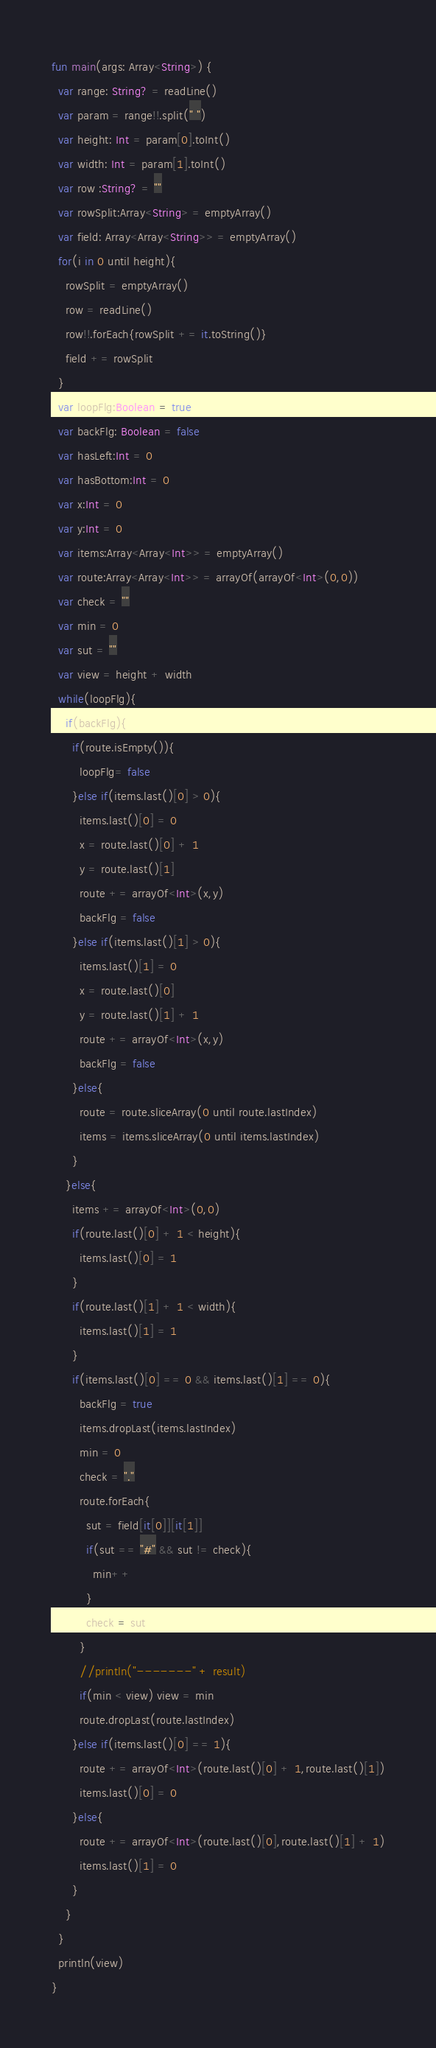<code> <loc_0><loc_0><loc_500><loc_500><_Kotlin_>fun main(args: Array<String>) {
  var range: String? = readLine()
  var param = range!!.split(" ")
  var height: Int = param[0].toInt()
  var width: Int = param[1].toInt()
  var row :String? = ""
  var rowSplit:Array<String> = emptyArray() 
  var field: Array<Array<String>> = emptyArray()
  for(i in 0 until height){
    rowSplit = emptyArray() 
    row = readLine()
    row!!.forEach{rowSplit += it.toString()}
    field += rowSplit
  }
  var loopFlg:Boolean = true
  var backFlg: Boolean = false
  var hasLeft:Int = 0
  var hasBottom:Int = 0
  var x:Int = 0
  var y:Int = 0
  var items:Array<Array<Int>> = emptyArray()
  var route:Array<Array<Int>> = arrayOf(arrayOf<Int>(0,0))
  var check = ""
  var min = 0
  var sut = ""
  var view = height + width
  while(loopFlg){
    if(backFlg){
      if(route.isEmpty()){
        loopFlg= false
      }else if(items.last()[0] > 0){
        items.last()[0] = 0
        x = route.last()[0] + 1
        y = route.last()[1]
        route += arrayOf<Int>(x,y)
        backFlg = false
      }else if(items.last()[1] > 0){
        items.last()[1] = 0
        x = route.last()[0]
        y = route.last()[1] + 1
        route += arrayOf<Int>(x,y)
        backFlg = false
      }else{
        route = route.sliceArray(0 until route.lastIndex)
        items = items.sliceArray(0 until items.lastIndex)
      }
    }else{
      items += arrayOf<Int>(0,0)
      if(route.last()[0] + 1 < height){
        items.last()[0] = 1
      }
      if(route.last()[1] + 1 < width){
        items.last()[1] = 1
      }
      if(items.last()[0] == 0 && items.last()[1] == 0){
        backFlg = true
        items.dropLast(items.lastIndex)
        min = 0
        check = "."
        route.forEach{
          sut = field[it[0]][it[1]]
          if(sut == "#" && sut != check){
            min++
          }
          check = sut
        }
        //println("-------" + result)
        if(min < view) view = min 
        route.dropLast(route.lastIndex)
      }else if(items.last()[0] == 1){
        route += arrayOf<Int>(route.last()[0] + 1,route.last()[1])
        items.last()[0] = 0
      }else{
        route += arrayOf<Int>(route.last()[0],route.last()[1] + 1)
        items.last()[1] = 0
      }
    }
  }
  println(view)
}</code> 